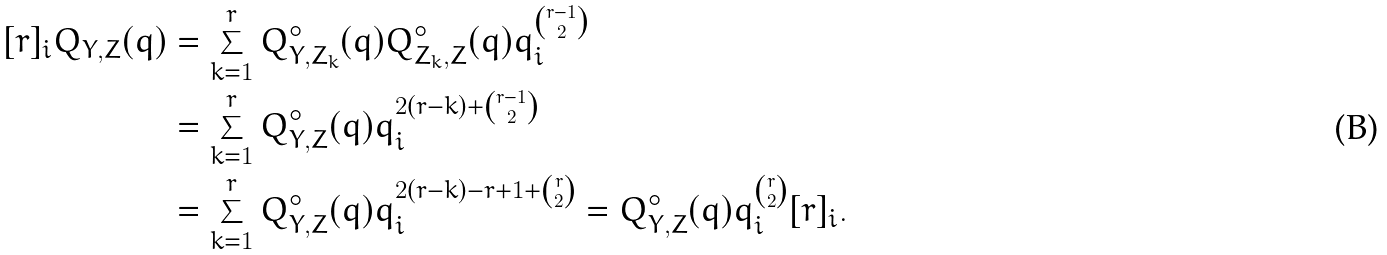<formula> <loc_0><loc_0><loc_500><loc_500>[ r ] _ { i } Q _ { Y , Z } ( q ) & = \sum _ { k = 1 } ^ { r } Q _ { Y , Z _ { k } } ^ { \circ } ( q ) Q _ { Z _ { k } , Z } ^ { \circ } ( q ) q _ { i } ^ { \binom { r - 1 } { 2 } } \\ & = \sum _ { k = 1 } ^ { r } Q _ { Y , Z } ^ { \circ } ( q ) q _ { i } ^ { 2 ( r - k ) + \binom { r - 1 } { 2 } } \\ & = \sum _ { k = 1 } ^ { r } Q _ { Y , Z } ^ { \circ } ( q ) q _ { i } ^ { 2 ( r - k ) - r + 1 + \binom { r } { 2 } } = Q _ { Y , Z } ^ { \circ } ( q ) q _ { i } ^ { \binom { r } { 2 } } [ r ] _ { i } .</formula> 